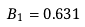<formula> <loc_0><loc_0><loc_500><loc_500>B _ { 1 } = 0 . 6 3 1</formula> 